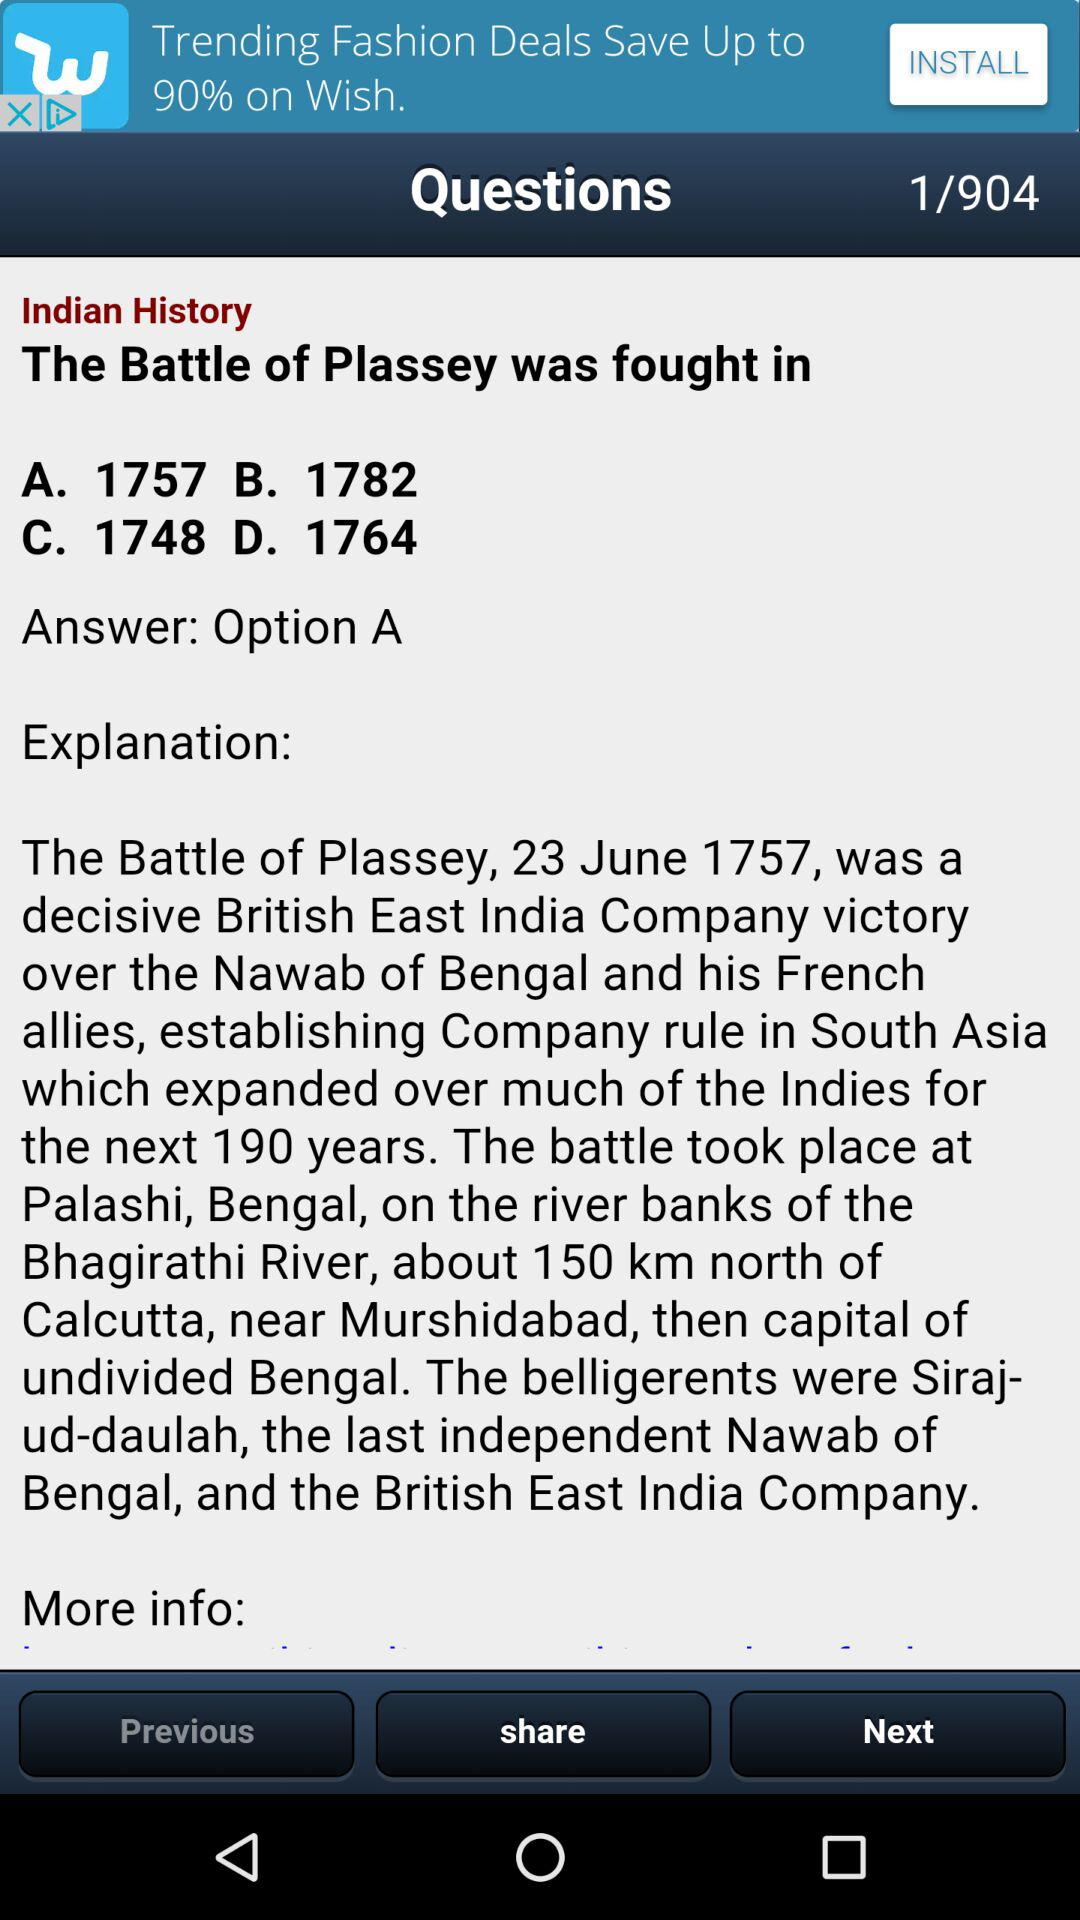On which date was the "Battle of Plassey" fought? The "Battle of Plassey" was fought on June 23, 1757. 